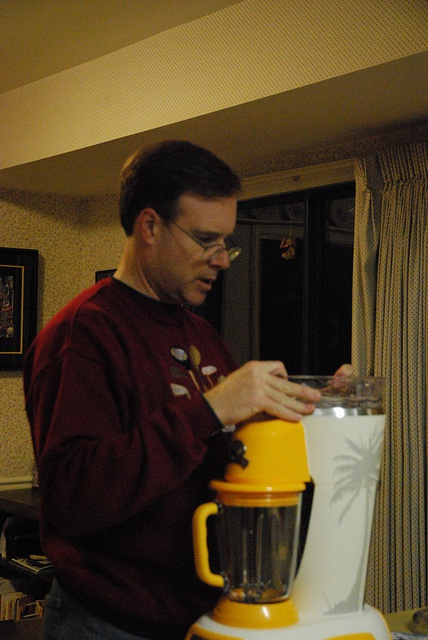Describe the objects in this image and their specific colors. I can see people in maroon, black, and olive tones in this image. 